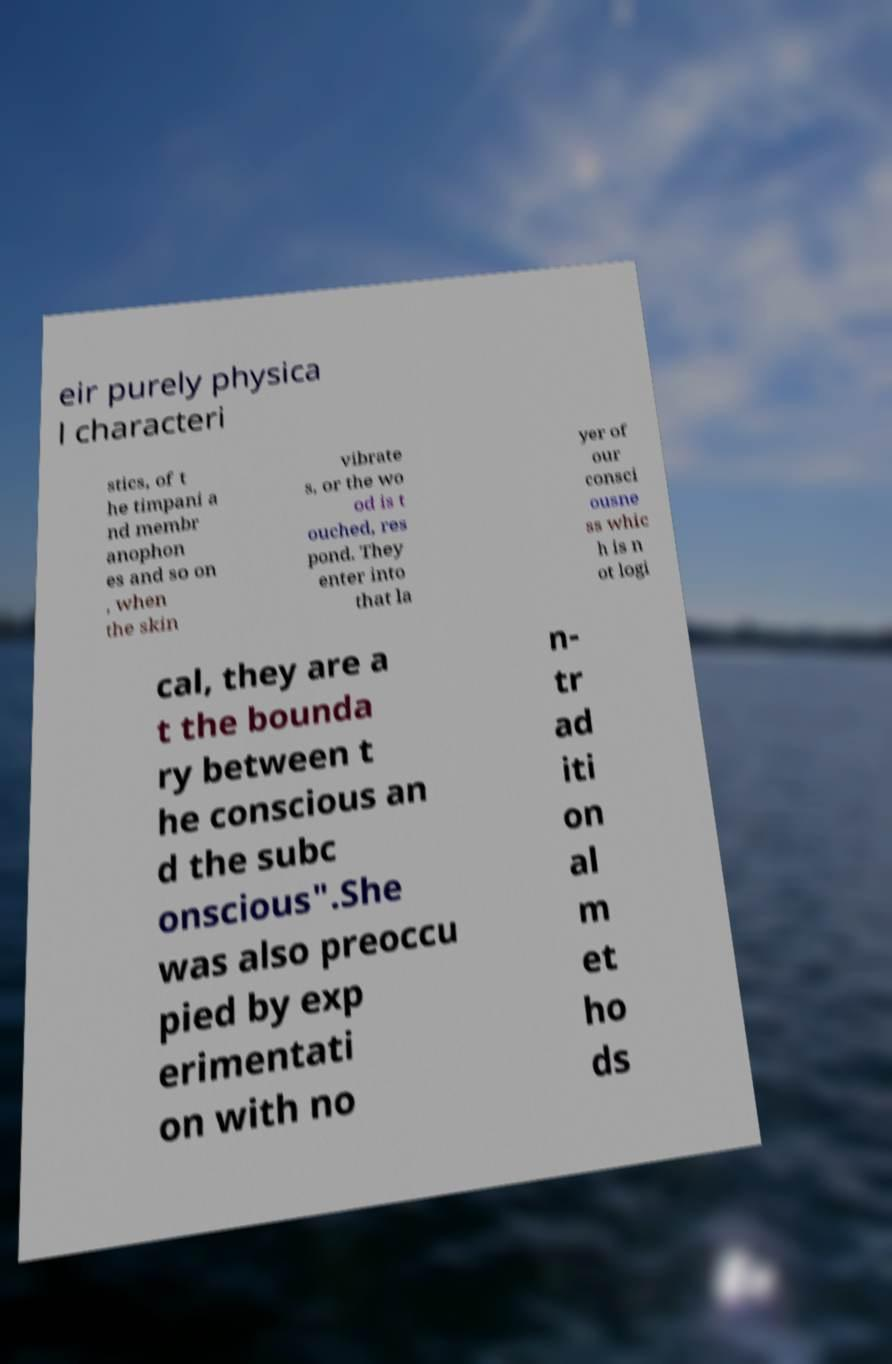Could you extract and type out the text from this image? eir purely physica l characteri stics, of t he timpani a nd membr anophon es and so on , when the skin vibrate s, or the wo od is t ouched, res pond. They enter into that la yer of our consci ousne ss whic h is n ot logi cal, they are a t the bounda ry between t he conscious an d the subc onscious".She was also preoccu pied by exp erimentati on with no n- tr ad iti on al m et ho ds 